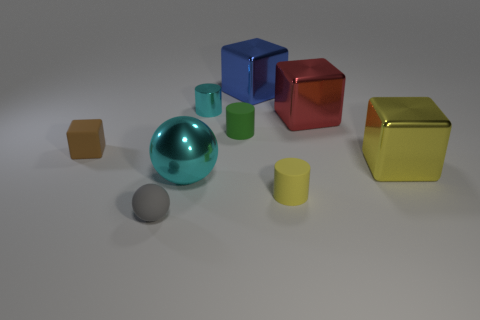What number of things are either large cyan metallic objects or green matte cylinders? 2 